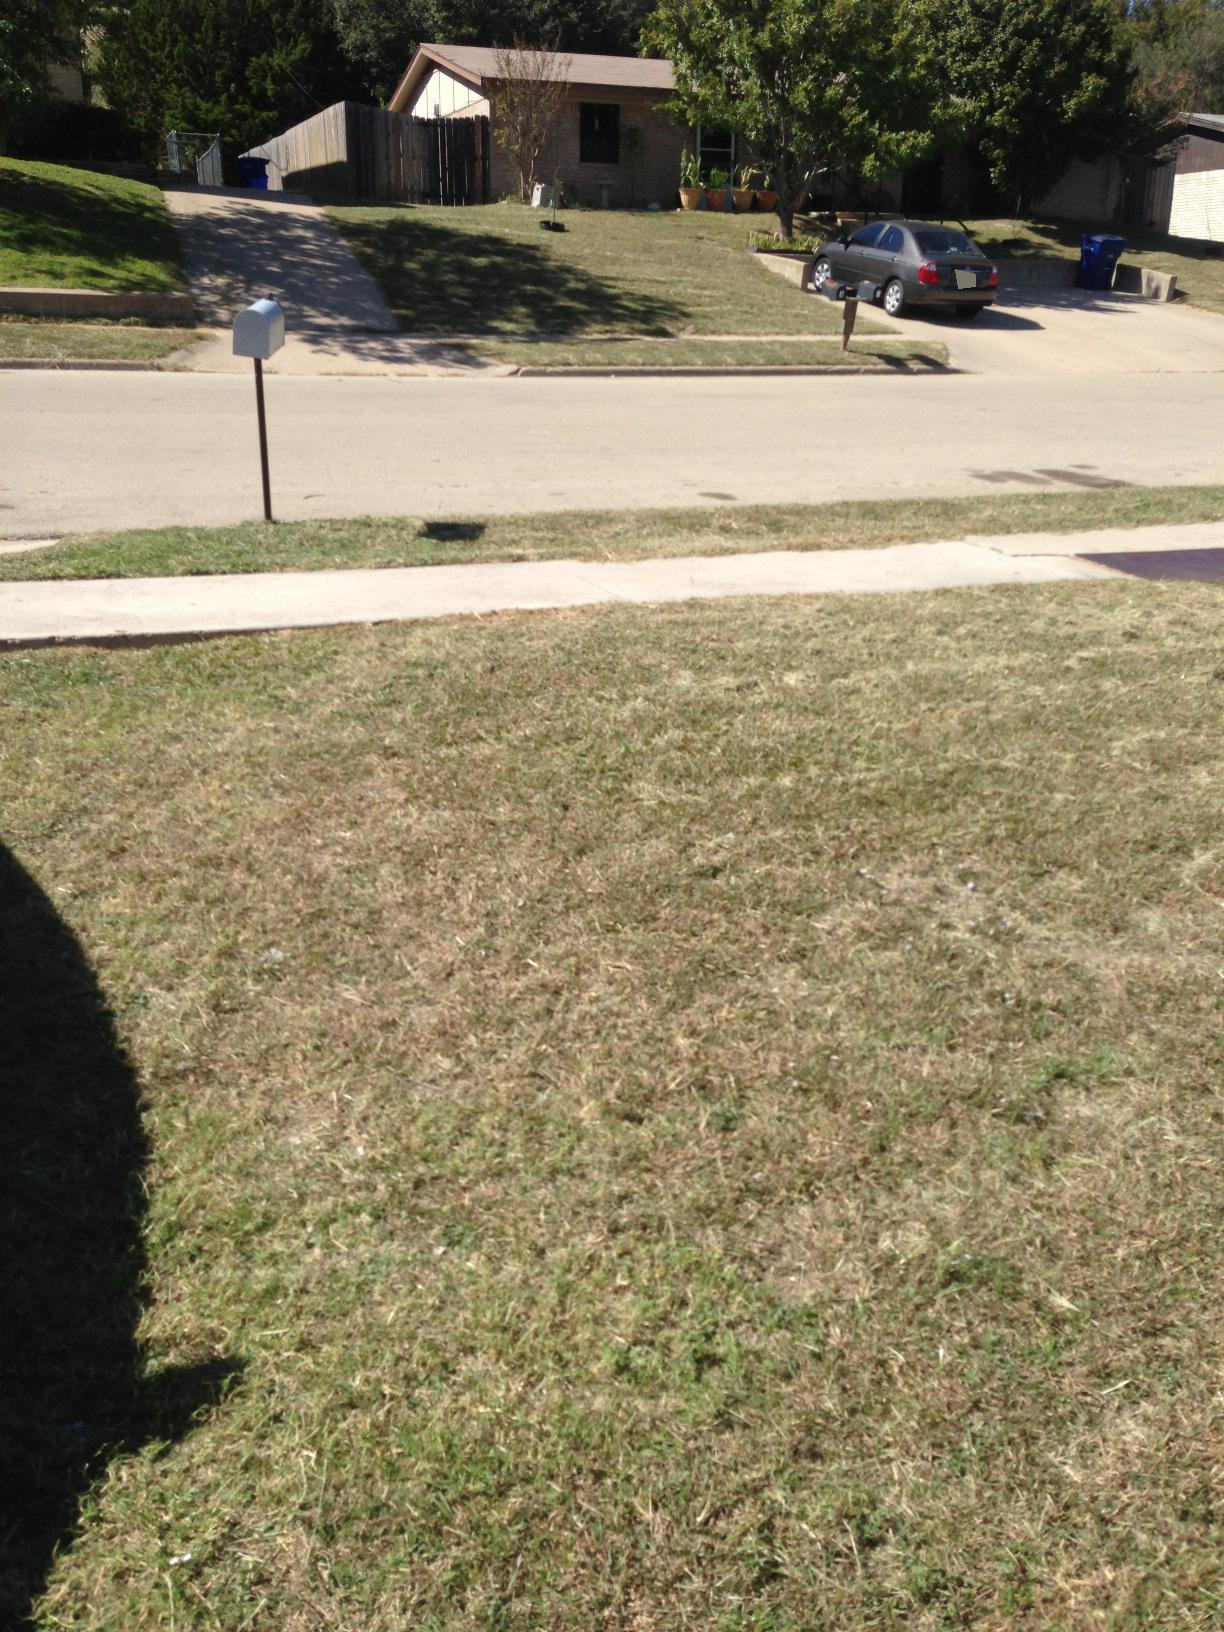What everyday activities might occur in this type of neighborhood? In a neighborhood like this, you might find residents engaging in various everyday activities such as walking their dogs, jogging, gardening, checking their mail, and children playing in the yard. Neighbors might greet each other and have casual conversations by the mailbox. Cars might occasionally pull in or out of driveways as people go about their daily commutes. 